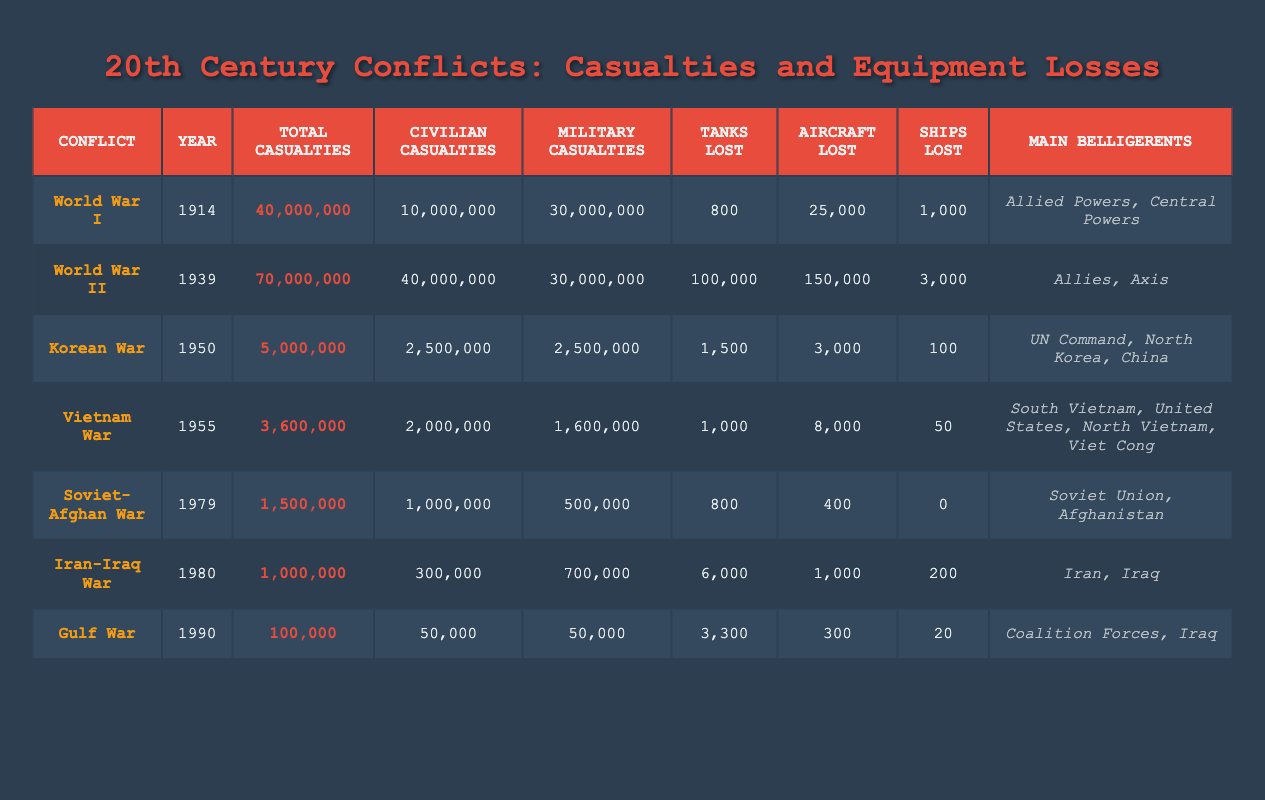What was the total number of casualties in World War II? The total number of casualties for World War II is listed directly under the "Total Casualties" column for that conflict, which shows 70,000,000.
Answer: 70,000,000 Which conflict had the highest number of military casualties? By reviewing the "Military Casualties" column for each conflict, the conflict with the highest military casualties is World War I with 30,000,000.
Answer: World War I How many more tanks were lost in World War II than in the Gulf War? To find the difference in tanks lost, subtract the number of tanks lost in the Gulf War (3,300) from the number lost in World War II (100,000): 100,000 - 3,300 = 96,700.
Answer: 96,700 Did the Iranian side lose more civilian casualties than military casualties in the Iran-Iraq War? The table shows that civilian casualties in the Iran-Iraq War are 300,000, while military casualties are 700,000. Since 300,000 is less than 700,000, the answer is no.
Answer: No What is the average number of aircraft lost in the conflicts listed? First, sum the total number of aircraft lost across all conflicts: 25,000 + 150,000 + 3,000 + 8,000 + 400 + 1,000 + 300 = 188,700. Then divide by the number of conflicts (7) to get the average: 188,700 / 7 = 26,957.14.
Answer: 26,957.14 Which conflict had the least number of total casualties among those listed? By examining the "Total Casualties" column, the conflict with the least number of total casualties is the Gulf War, which is listed as 100,000.
Answer: Gulf War If you combine the civilian casualties from the Korean War and the Vietnam War, what is the total? Add the civilian casualties from the Korean War (2,500,000) and the Vietnam War (2,000,000): 2,500,000 + 2,000,000 = 4,500,000.
Answer: 4,500,000 Was the Soviet-Afghan War primarily fought between the Soviet Union and Iraq? The table shows the main belligerents of the Soviet-Afghan War as the Soviet Union and Afghanistan, not Iraq. Therefore, the statement is false.
Answer: No 